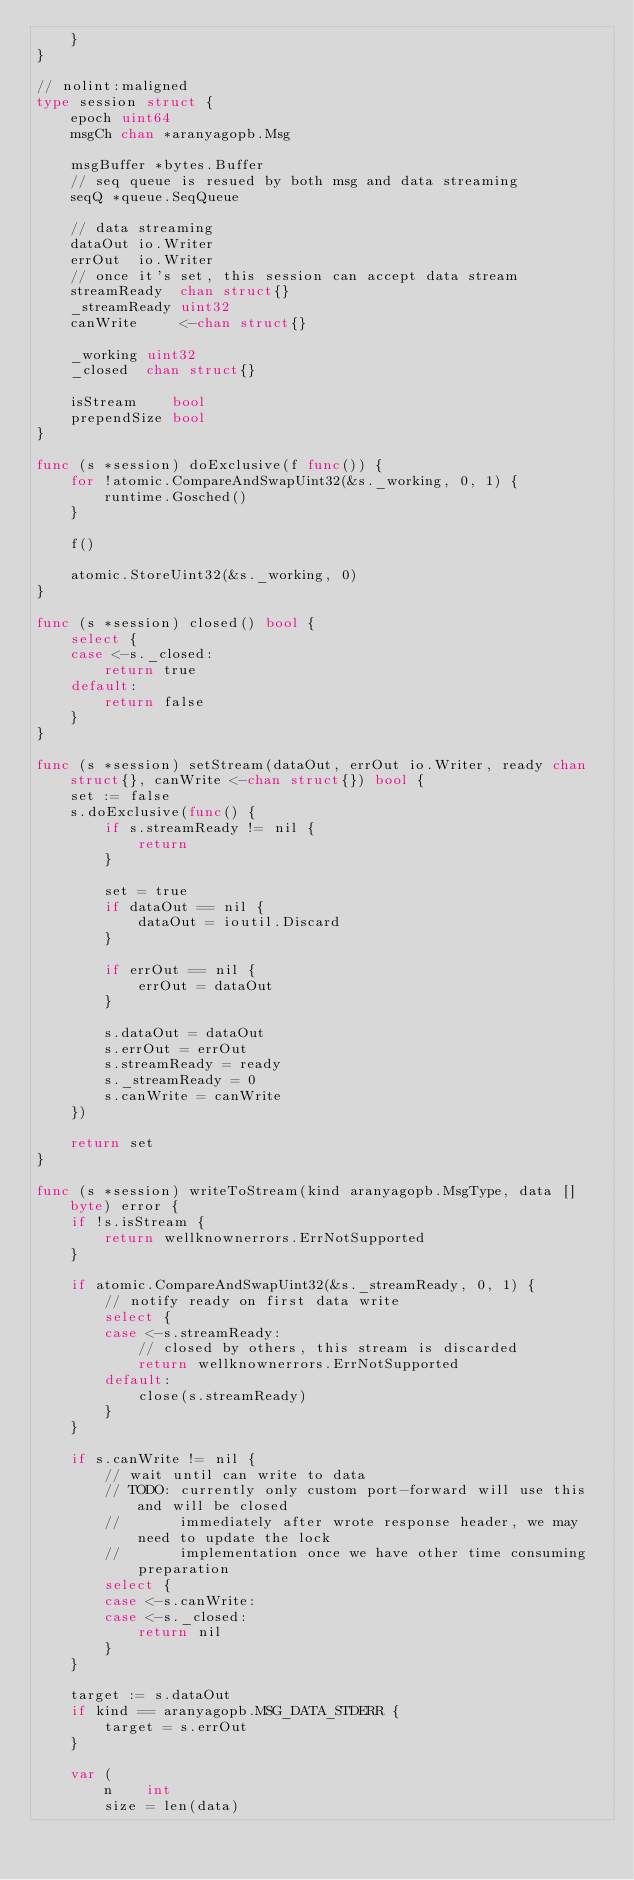Convert code to text. <code><loc_0><loc_0><loc_500><loc_500><_Go_>	}
}

// nolint:maligned
type session struct {
	epoch uint64
	msgCh chan *aranyagopb.Msg

	msgBuffer *bytes.Buffer
	// seq queue is resued by both msg and data streaming
	seqQ *queue.SeqQueue

	// data streaming
	dataOut io.Writer
	errOut  io.Writer
	// once it's set, this session can accept data stream
	streamReady  chan struct{}
	_streamReady uint32
	canWrite     <-chan struct{}

	_working uint32
	_closed  chan struct{}

	isStream    bool
	prependSize bool
}

func (s *session) doExclusive(f func()) {
	for !atomic.CompareAndSwapUint32(&s._working, 0, 1) {
		runtime.Gosched()
	}

	f()

	atomic.StoreUint32(&s._working, 0)
}

func (s *session) closed() bool {
	select {
	case <-s._closed:
		return true
	default:
		return false
	}
}

func (s *session) setStream(dataOut, errOut io.Writer, ready chan struct{}, canWrite <-chan struct{}) bool {
	set := false
	s.doExclusive(func() {
		if s.streamReady != nil {
			return
		}

		set = true
		if dataOut == nil {
			dataOut = ioutil.Discard
		}

		if errOut == nil {
			errOut = dataOut
		}

		s.dataOut = dataOut
		s.errOut = errOut
		s.streamReady = ready
		s._streamReady = 0
		s.canWrite = canWrite
	})

	return set
}

func (s *session) writeToStream(kind aranyagopb.MsgType, data []byte) error {
	if !s.isStream {
		return wellknownerrors.ErrNotSupported
	}

	if atomic.CompareAndSwapUint32(&s._streamReady, 0, 1) {
		// notify ready on first data write
		select {
		case <-s.streamReady:
			// closed by others, this stream is discarded
			return wellknownerrors.ErrNotSupported
		default:
			close(s.streamReady)
		}
	}

	if s.canWrite != nil {
		// wait until can write to data
		// TODO: currently only custom port-forward will use this and will be closed
		//       immediately after wrote response header, we may need to update the lock
		//       implementation once we have other time consuming preparation
		select {
		case <-s.canWrite:
		case <-s._closed:
			return nil
		}
	}

	target := s.dataOut
	if kind == aranyagopb.MSG_DATA_STDERR {
		target = s.errOut
	}

	var (
		n    int
		size = len(data)</code> 